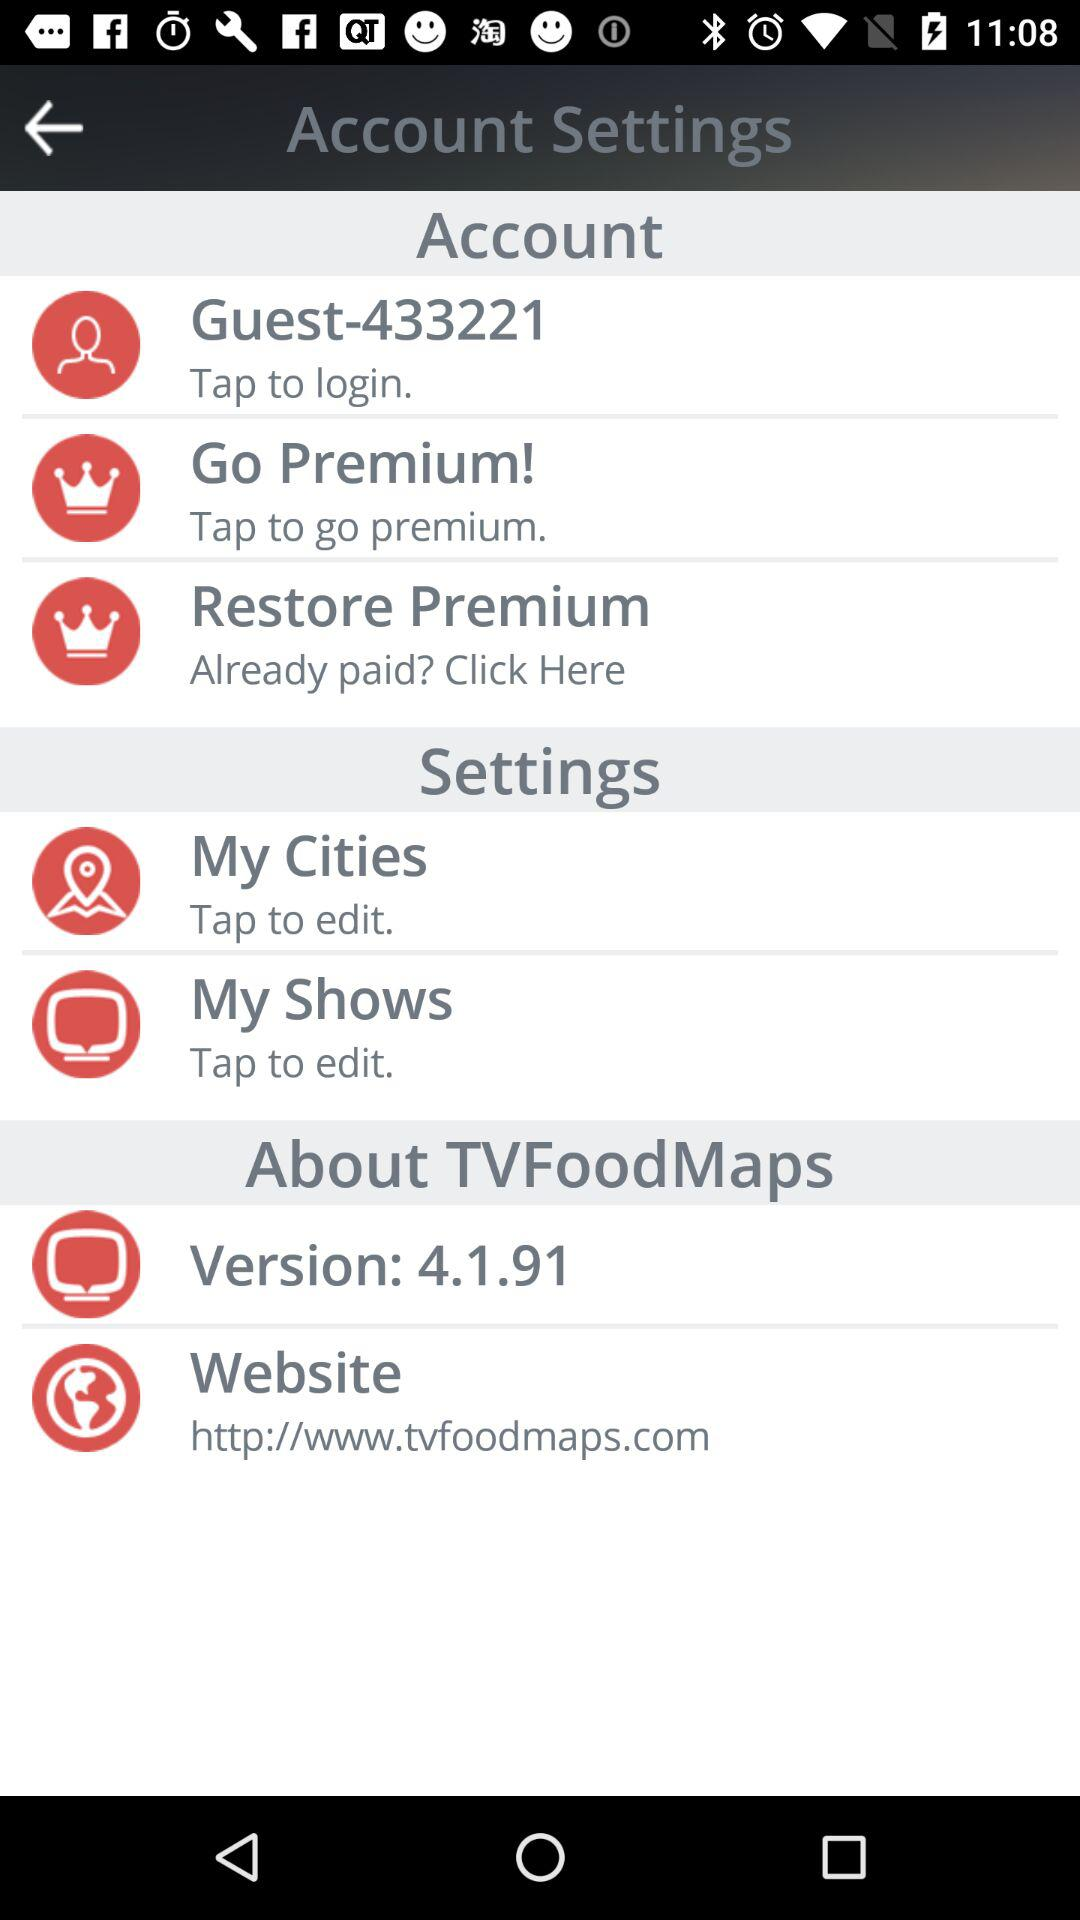Which cities are selected by the user?
When the provided information is insufficient, respond with <no answer>. <no answer> 